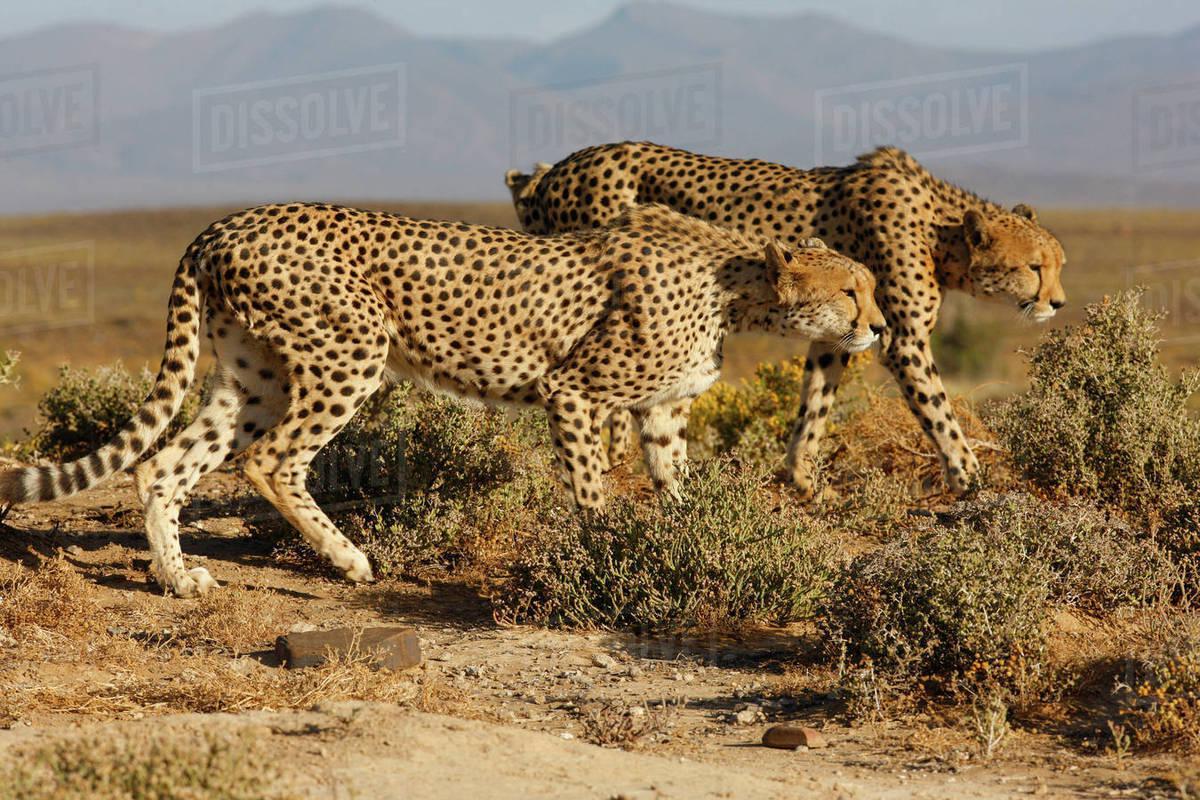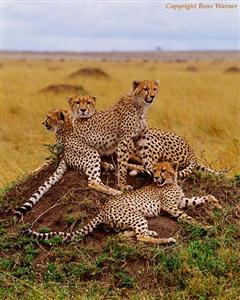The first image is the image on the left, the second image is the image on the right. Analyze the images presented: Is the assertion "In the leftmost image there are exactly five cheetahs sitting down." valid? Answer yes or no. No. The first image is the image on the left, the second image is the image on the right. Assess this claim about the two images: "The left image contains more cheetahs than the right image.". Correct or not? Answer yes or no. No. 